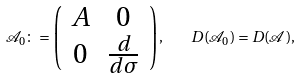<formula> <loc_0><loc_0><loc_500><loc_500>\mathcal { A } _ { 0 } \colon = \left ( \begin{array} { c c } A & 0 \\ 0 & \frac { d } { d \sigma } \end{array} \right ) , \quad D ( \mathcal { A } _ { 0 } ) = D ( \mathcal { A } ) ,</formula> 